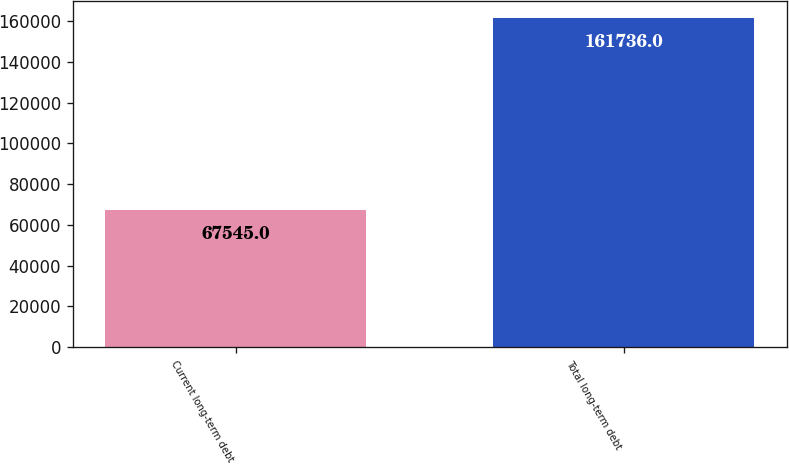Convert chart. <chart><loc_0><loc_0><loc_500><loc_500><bar_chart><fcel>Current long-term debt<fcel>Total long-term debt<nl><fcel>67545<fcel>161736<nl></chart> 